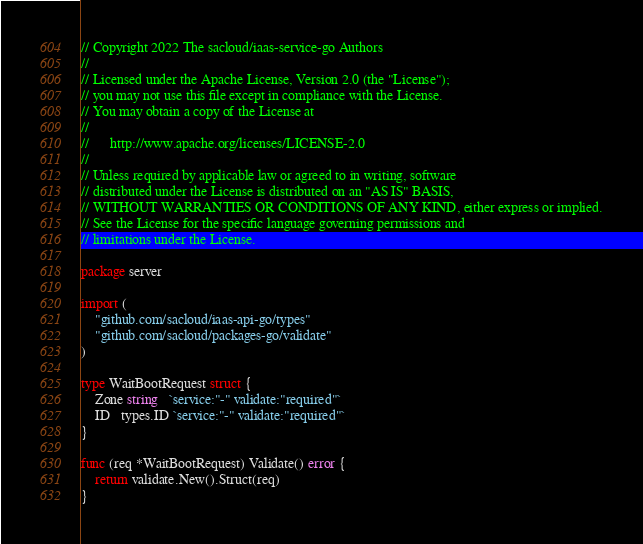<code> <loc_0><loc_0><loc_500><loc_500><_Go_>// Copyright 2022 The sacloud/iaas-service-go Authors
//
// Licensed under the Apache License, Version 2.0 (the "License");
// you may not use this file except in compliance with the License.
// You may obtain a copy of the License at
//
//      http://www.apache.org/licenses/LICENSE-2.0
//
// Unless required by applicable law or agreed to in writing, software
// distributed under the License is distributed on an "AS IS" BASIS,
// WITHOUT WARRANTIES OR CONDITIONS OF ANY KIND, either express or implied.
// See the License for the specific language governing permissions and
// limitations under the License.

package server

import (
	"github.com/sacloud/iaas-api-go/types"
	"github.com/sacloud/packages-go/validate"
)

type WaitBootRequest struct {
	Zone string   `service:"-" validate:"required"`
	ID   types.ID `service:"-" validate:"required"`
}

func (req *WaitBootRequest) Validate() error {
	return validate.New().Struct(req)
}
</code> 